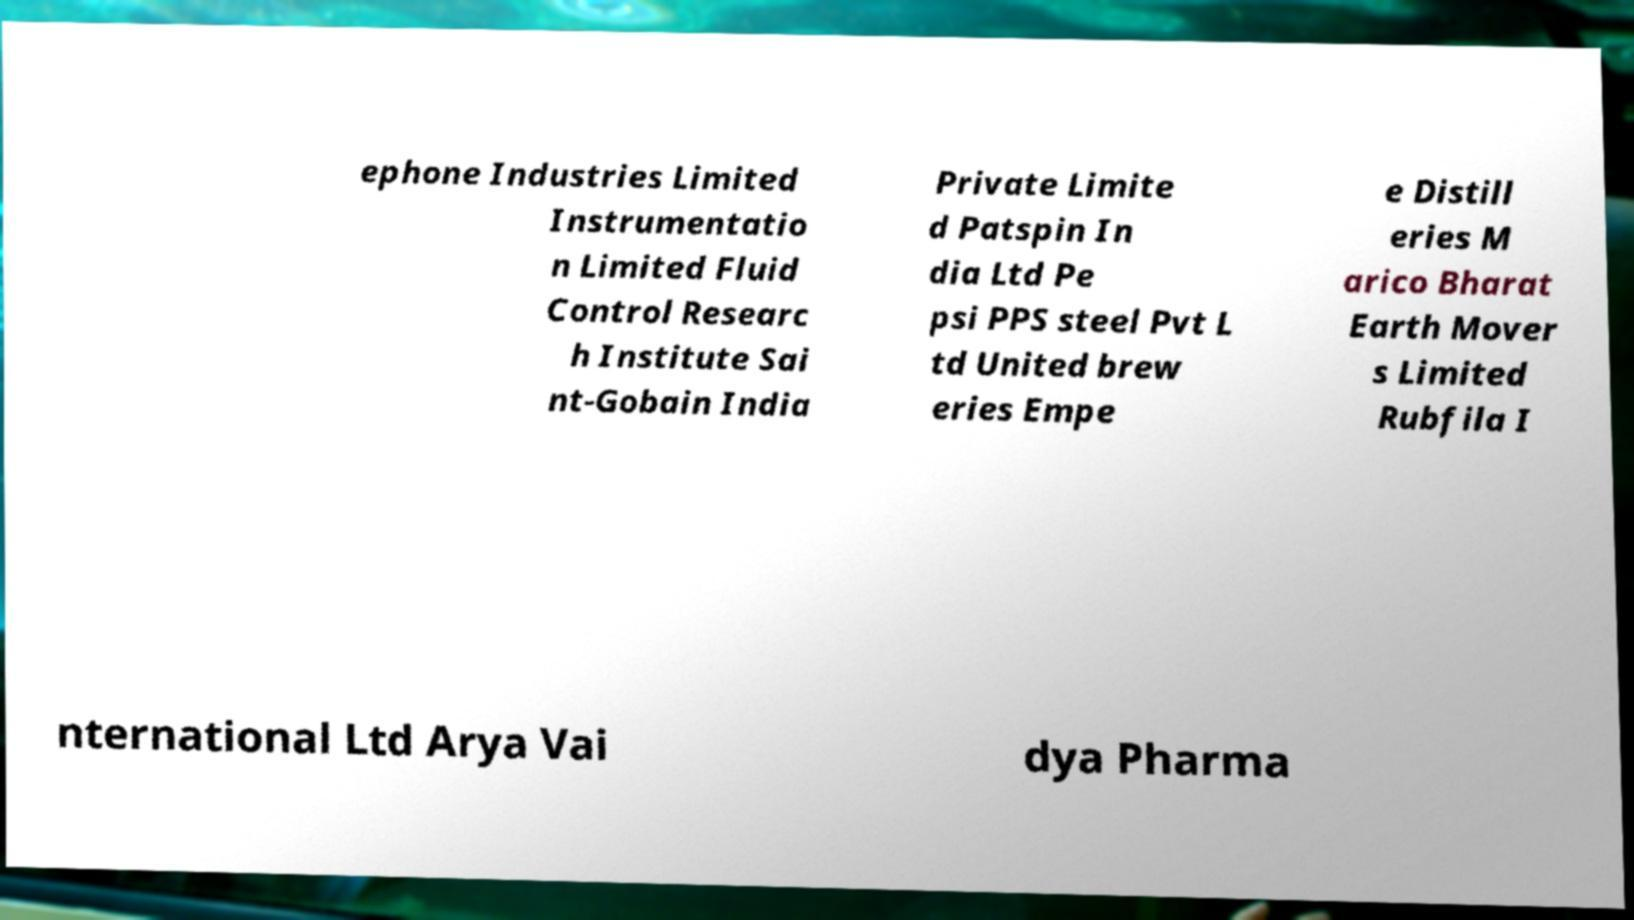Please read and relay the text visible in this image. What does it say? ephone Industries Limited Instrumentatio n Limited Fluid Control Researc h Institute Sai nt-Gobain India Private Limite d Patspin In dia Ltd Pe psi PPS steel Pvt L td United brew eries Empe e Distill eries M arico Bharat Earth Mover s Limited Rubfila I nternational Ltd Arya Vai dya Pharma 